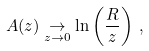<formula> <loc_0><loc_0><loc_500><loc_500>A ( z ) \underset { z \rightarrow 0 } { \rightarrow } \ln \left ( \frac { R } { z } \right ) \, ,</formula> 